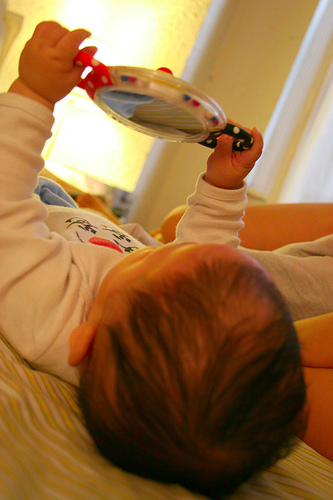<image>
Is the toy next to the wall? No. The toy is not positioned next to the wall. They are located in different areas of the scene. 